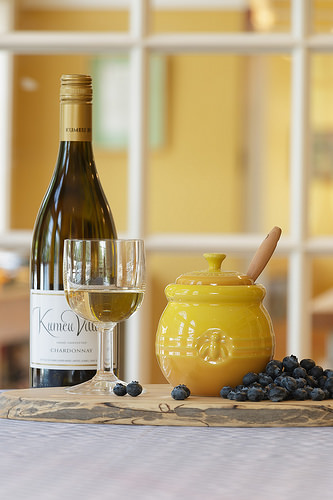<image>
Can you confirm if the wine glass is behind the wine bottle? No. The wine glass is not behind the wine bottle. From this viewpoint, the wine glass appears to be positioned elsewhere in the scene. 